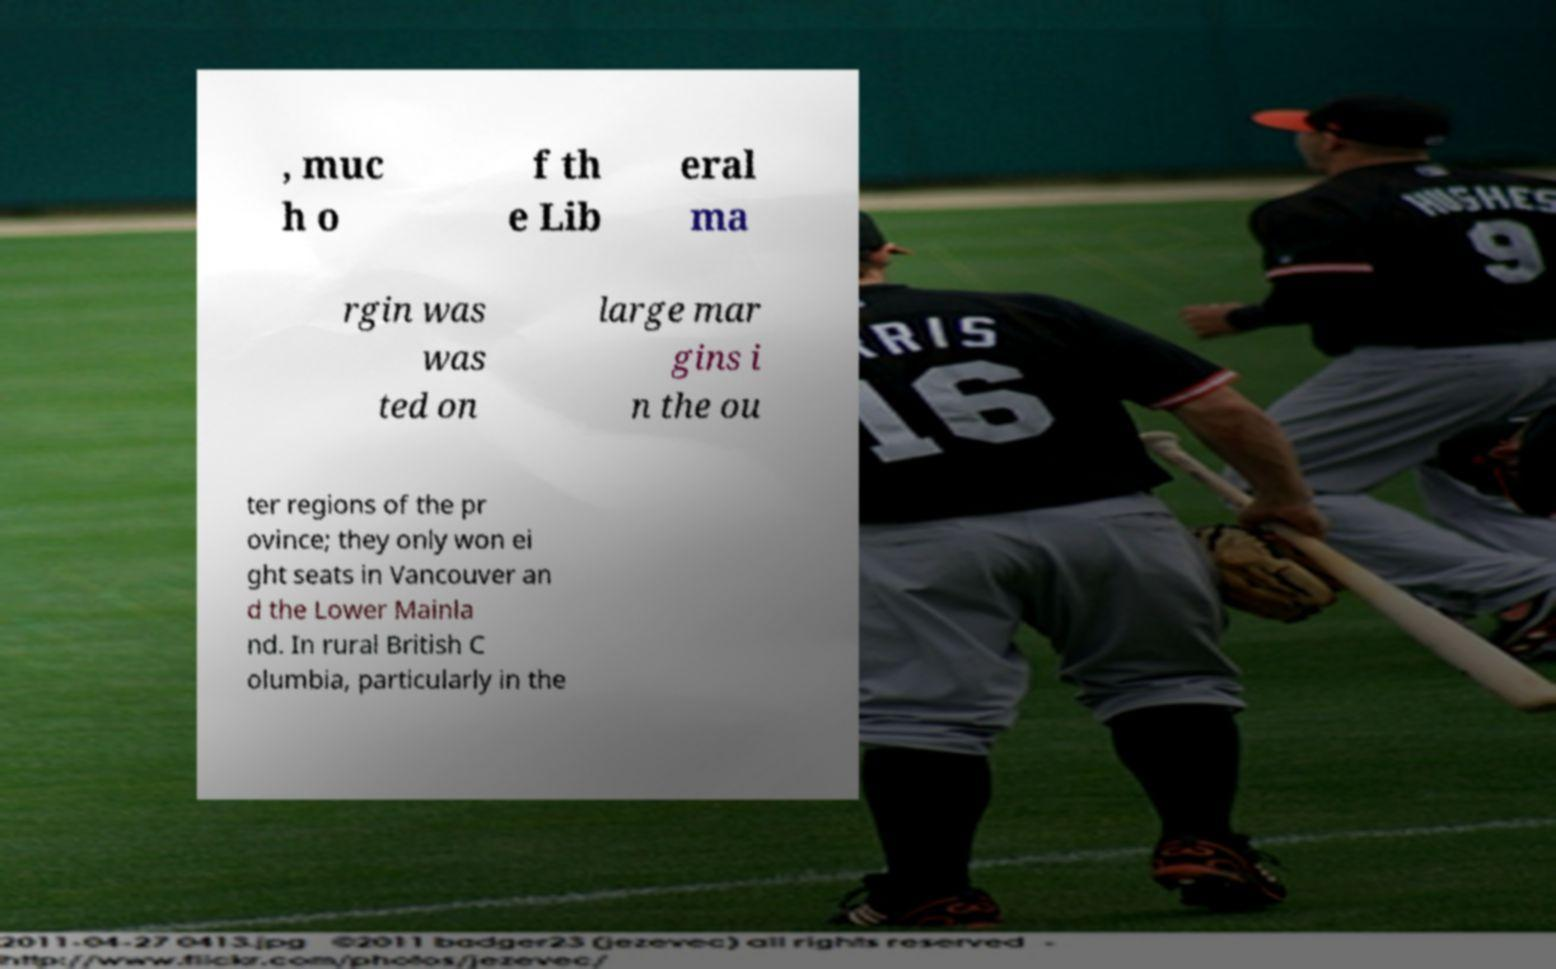For documentation purposes, I need the text within this image transcribed. Could you provide that? , muc h o f th e Lib eral ma rgin was was ted on large mar gins i n the ou ter regions of the pr ovince; they only won ei ght seats in Vancouver an d the Lower Mainla nd. In rural British C olumbia, particularly in the 